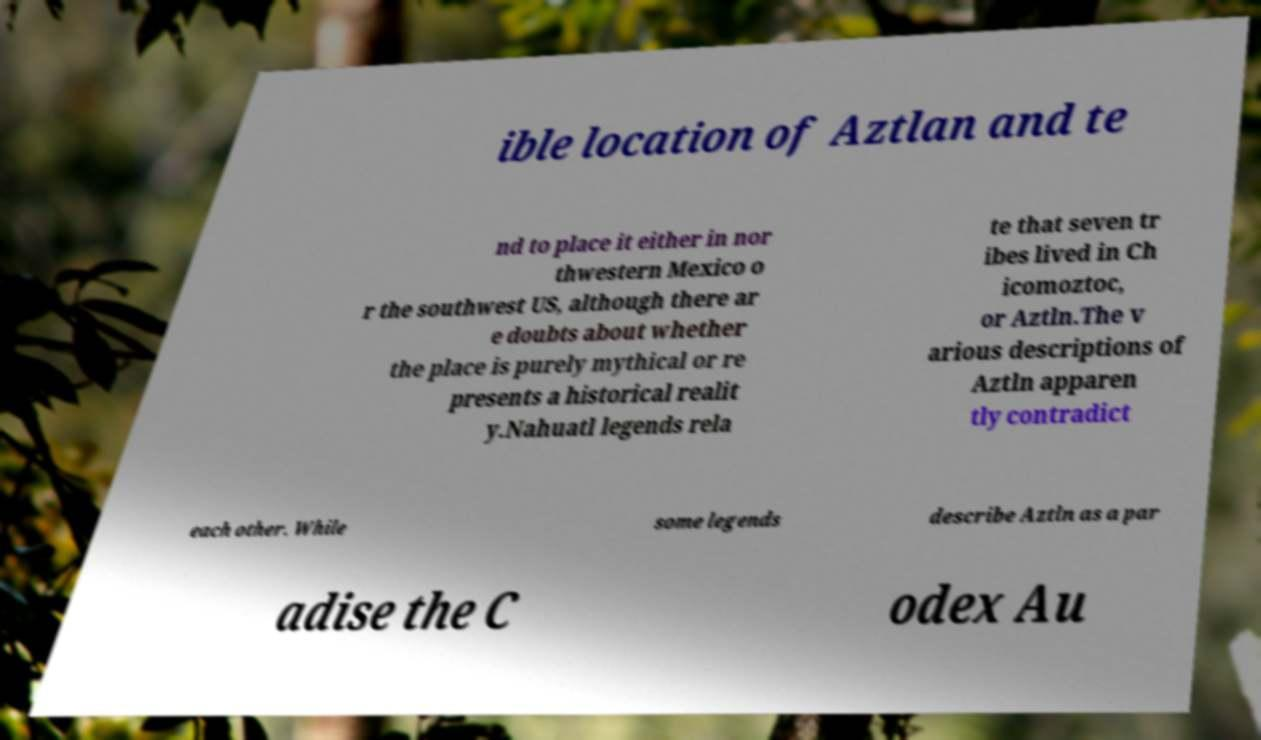What messages or text are displayed in this image? I need them in a readable, typed format. ible location of Aztlan and te nd to place it either in nor thwestern Mexico o r the southwest US, although there ar e doubts about whether the place is purely mythical or re presents a historical realit y.Nahuatl legends rela te that seven tr ibes lived in Ch icomoztoc, or Aztln.The v arious descriptions of Aztln apparen tly contradict each other. While some legends describe Aztln as a par adise the C odex Au 